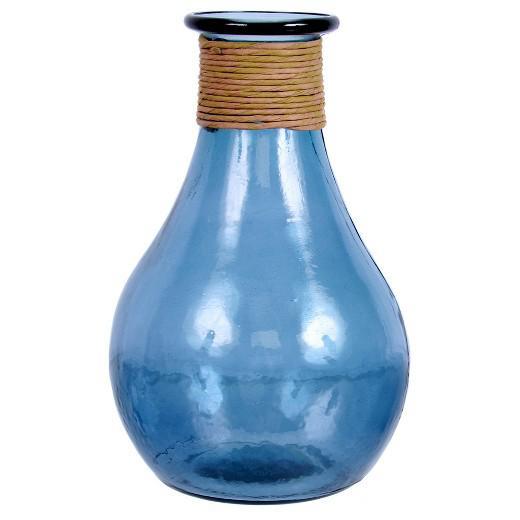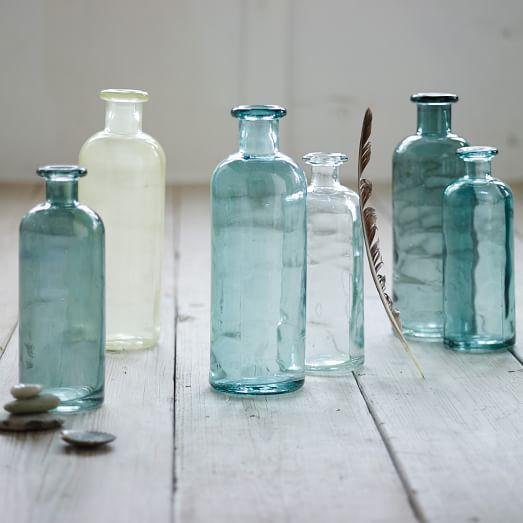The first image is the image on the left, the second image is the image on the right. For the images displayed, is the sentence "There are at least 5 glass jars." factually correct? Answer yes or no. Yes. The first image is the image on the left, the second image is the image on the right. Analyze the images presented: Is the assertion "The vases are made of repurposed bottles." valid? Answer yes or no. Yes. 